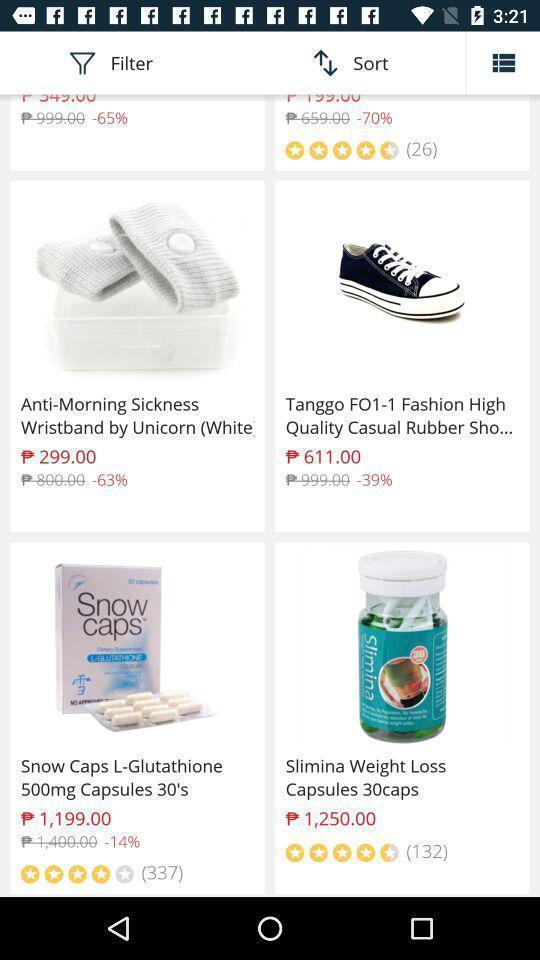Tell me about the visual elements in this screen capture. Screen showing various items with prices in shopping app. 